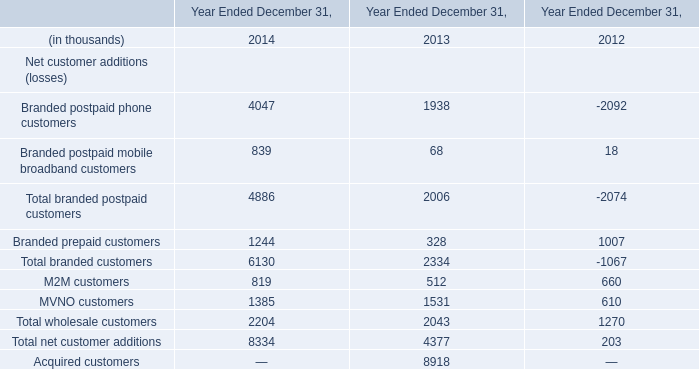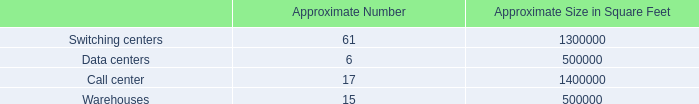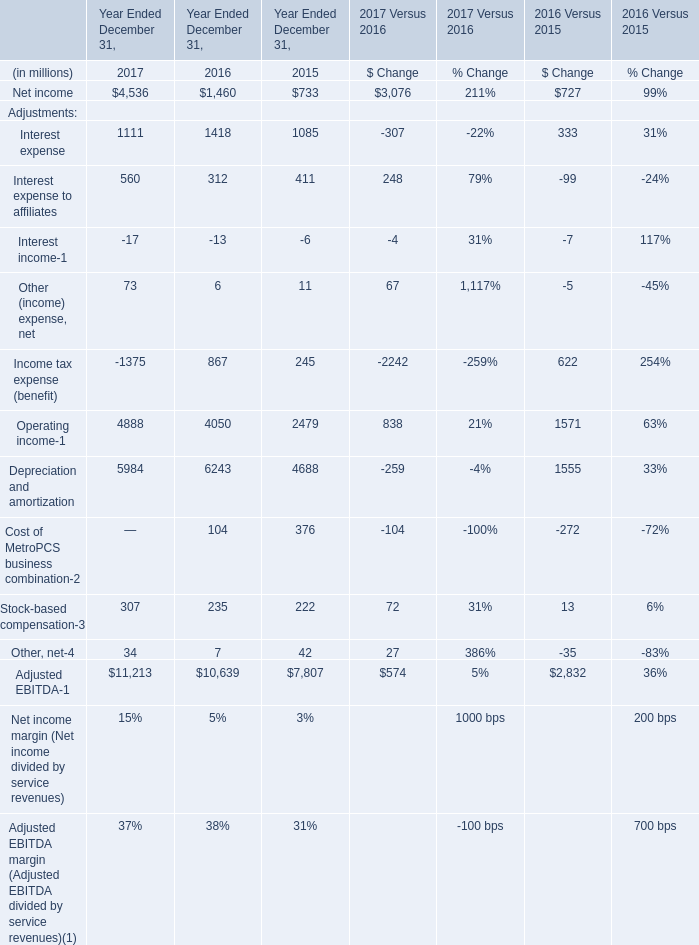What is the total amount of Branded postpaid phone customers of Year Ended December 31, 2014, and Warehouses of Approximate Size in Square Feet ? 
Computations: (4047.0 + 500000.0)
Answer: 504047.0. 